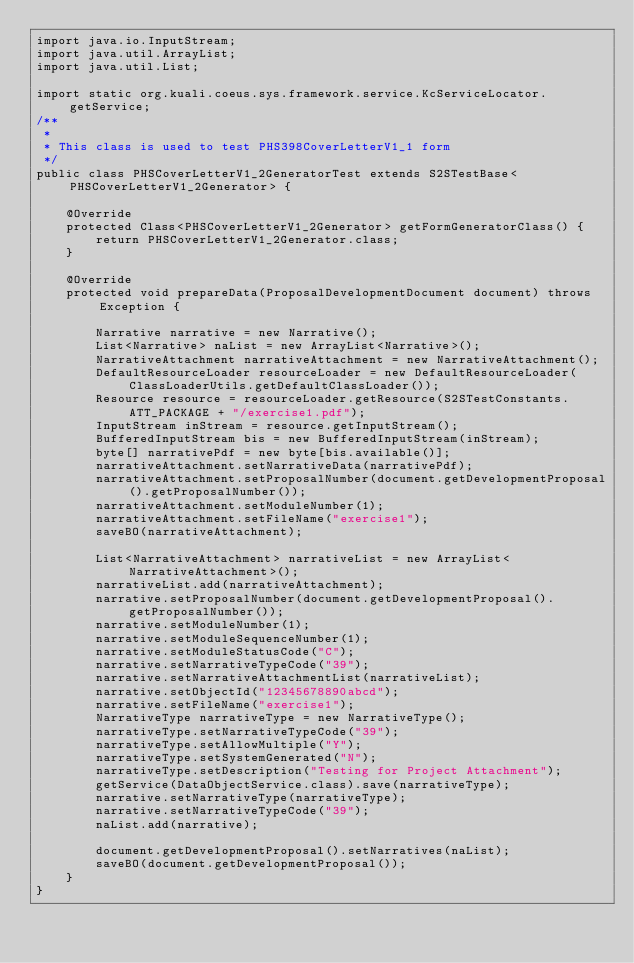Convert code to text. <code><loc_0><loc_0><loc_500><loc_500><_Java_>import java.io.InputStream;
import java.util.ArrayList;
import java.util.List;

import static org.kuali.coeus.sys.framework.service.KcServiceLocator.getService;
/**
 * 
 * This class is used to test PHS398CoverLetterV1_1 form
 */
public class PHSCoverLetterV1_2GeneratorTest extends S2STestBase<PHSCoverLetterV1_2Generator> {

    @Override
    protected Class<PHSCoverLetterV1_2Generator> getFormGeneratorClass() {
        return PHSCoverLetterV1_2Generator.class;
    }

    @Override
    protected void prepareData(ProposalDevelopmentDocument document) throws Exception {

        Narrative narrative = new Narrative();
        List<Narrative> naList = new ArrayList<Narrative>();
        NarrativeAttachment narrativeAttachment = new NarrativeAttachment();
        DefaultResourceLoader resourceLoader = new DefaultResourceLoader(ClassLoaderUtils.getDefaultClassLoader());
        Resource resource = resourceLoader.getResource(S2STestConstants.ATT_PACKAGE + "/exercise1.pdf");
        InputStream inStream = resource.getInputStream();
        BufferedInputStream bis = new BufferedInputStream(inStream);
        byte[] narrativePdf = new byte[bis.available()];
        narrativeAttachment.setNarrativeData(narrativePdf);
        narrativeAttachment.setProposalNumber(document.getDevelopmentProposal().getProposalNumber());
        narrativeAttachment.setModuleNumber(1);
        narrativeAttachment.setFileName("exercise1");
        saveBO(narrativeAttachment);

        List<NarrativeAttachment> narrativeList = new ArrayList<NarrativeAttachment>();
        narrativeList.add(narrativeAttachment);
        narrative.setProposalNumber(document.getDevelopmentProposal().getProposalNumber());
        narrative.setModuleNumber(1);
        narrative.setModuleSequenceNumber(1);
        narrative.setModuleStatusCode("C");
        narrative.setNarrativeTypeCode("39");
        narrative.setNarrativeAttachmentList(narrativeList);
        narrative.setObjectId("12345678890abcd");
        narrative.setFileName("exercise1");
        NarrativeType narrativeType = new NarrativeType();
        narrativeType.setNarrativeTypeCode("39");
        narrativeType.setAllowMultiple("Y");
        narrativeType.setSystemGenerated("N");
        narrativeType.setDescription("Testing for Project Attachment");
        getService(DataObjectService.class).save(narrativeType);
        narrative.setNarrativeType(narrativeType);
        narrative.setNarrativeTypeCode("39");
        naList.add(narrative);

        document.getDevelopmentProposal().setNarratives(naList);
        saveBO(document.getDevelopmentProposal());
    }
}
</code> 